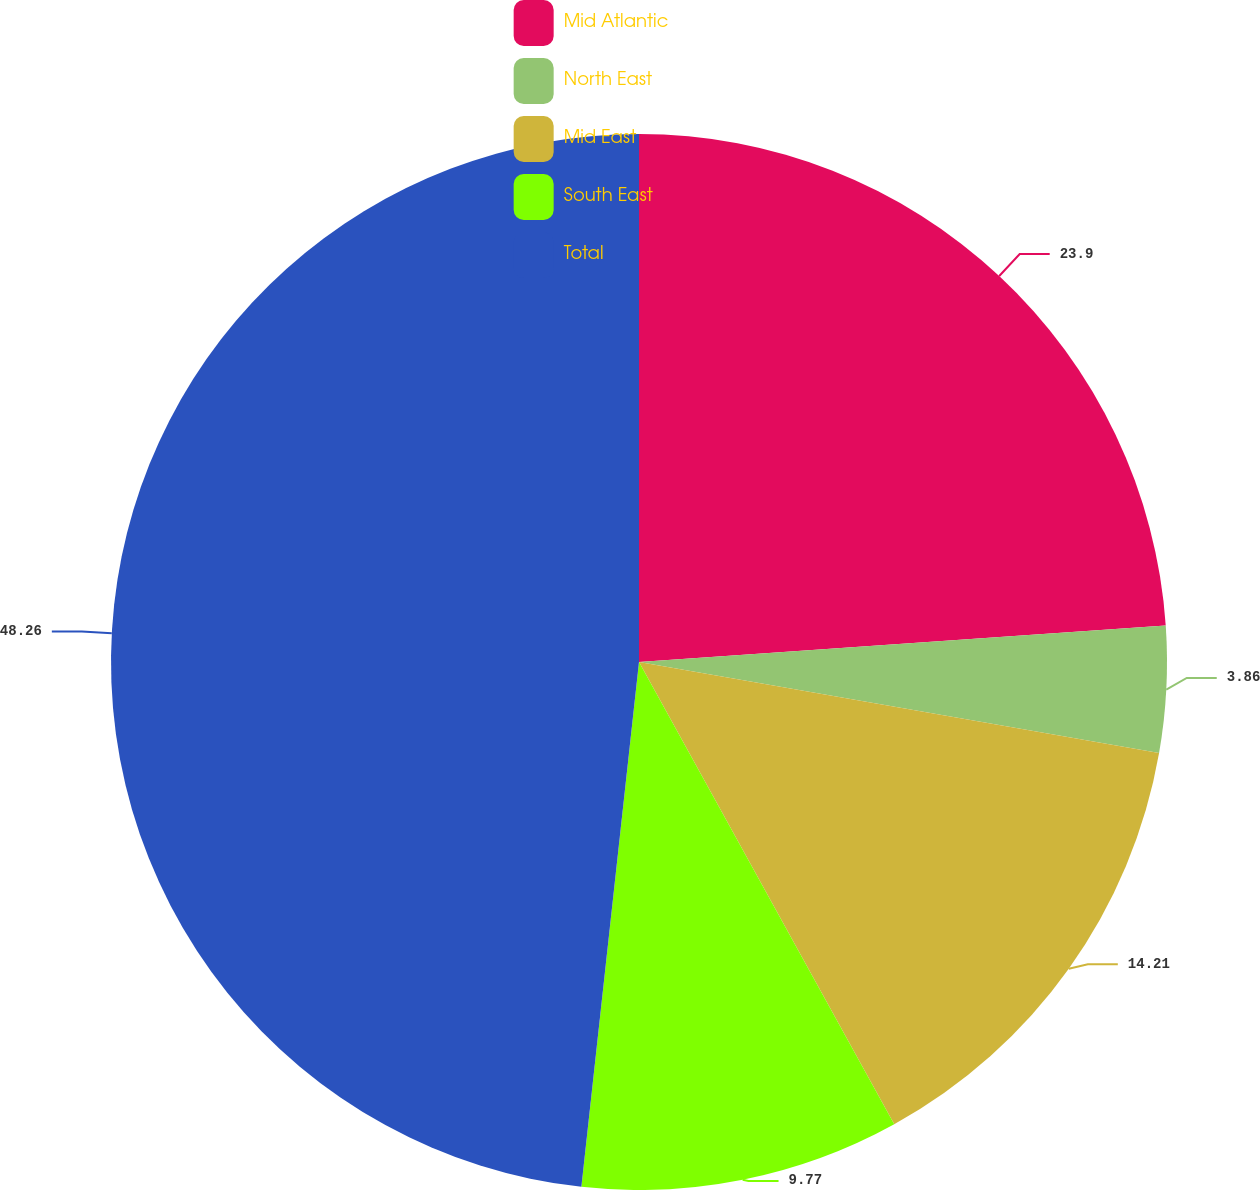Convert chart to OTSL. <chart><loc_0><loc_0><loc_500><loc_500><pie_chart><fcel>Mid Atlantic<fcel>North East<fcel>Mid East<fcel>South East<fcel>Total<nl><fcel>23.9%<fcel>3.86%<fcel>14.21%<fcel>9.77%<fcel>48.26%<nl></chart> 